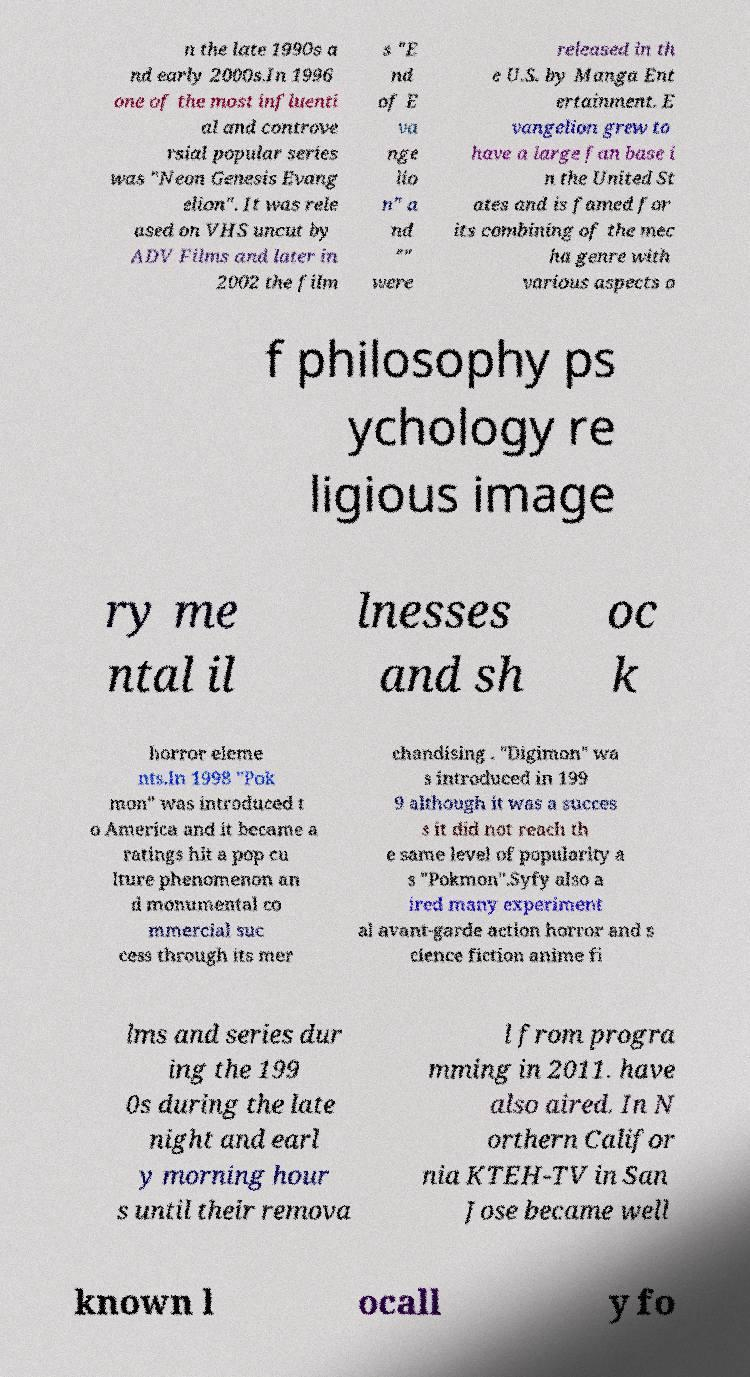There's text embedded in this image that I need extracted. Can you transcribe it verbatim? n the late 1990s a nd early 2000s.In 1996 one of the most influenti al and controve rsial popular series was "Neon Genesis Evang elion". It was rele ased on VHS uncut by ADV Films and later in 2002 the film s "E nd of E va nge lio n" a nd "" were released in th e U.S. by Manga Ent ertainment. E vangelion grew to have a large fan base i n the United St ates and is famed for its combining of the mec ha genre with various aspects o f philosophy ps ychology re ligious image ry me ntal il lnesses and sh oc k horror eleme nts.In 1998 "Pok mon" was introduced t o America and it became a ratings hit a pop cu lture phenomenon an d monumental co mmercial suc cess through its mer chandising . "Digimon" wa s introduced in 199 9 although it was a succes s it did not reach th e same level of popularity a s "Pokmon".Syfy also a ired many experiment al avant-garde action horror and s cience fiction anime fi lms and series dur ing the 199 0s during the late night and earl y morning hour s until their remova l from progra mming in 2011. have also aired. In N orthern Califor nia KTEH-TV in San Jose became well known l ocall y fo 